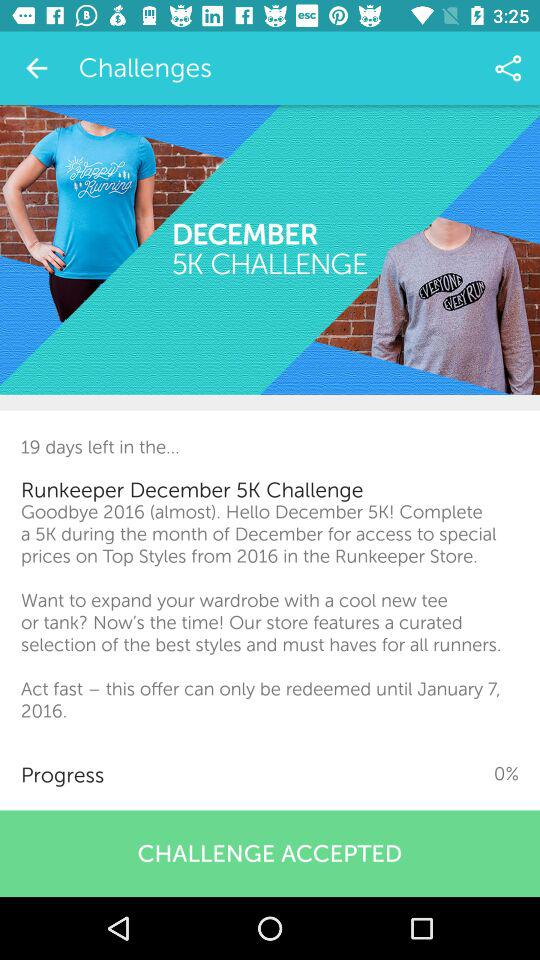How many days are left in the challenge?
Answer the question using a single word or phrase. 19 